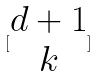<formula> <loc_0><loc_0><loc_500><loc_500>[ \begin{matrix} d + 1 \\ k \end{matrix} ]</formula> 